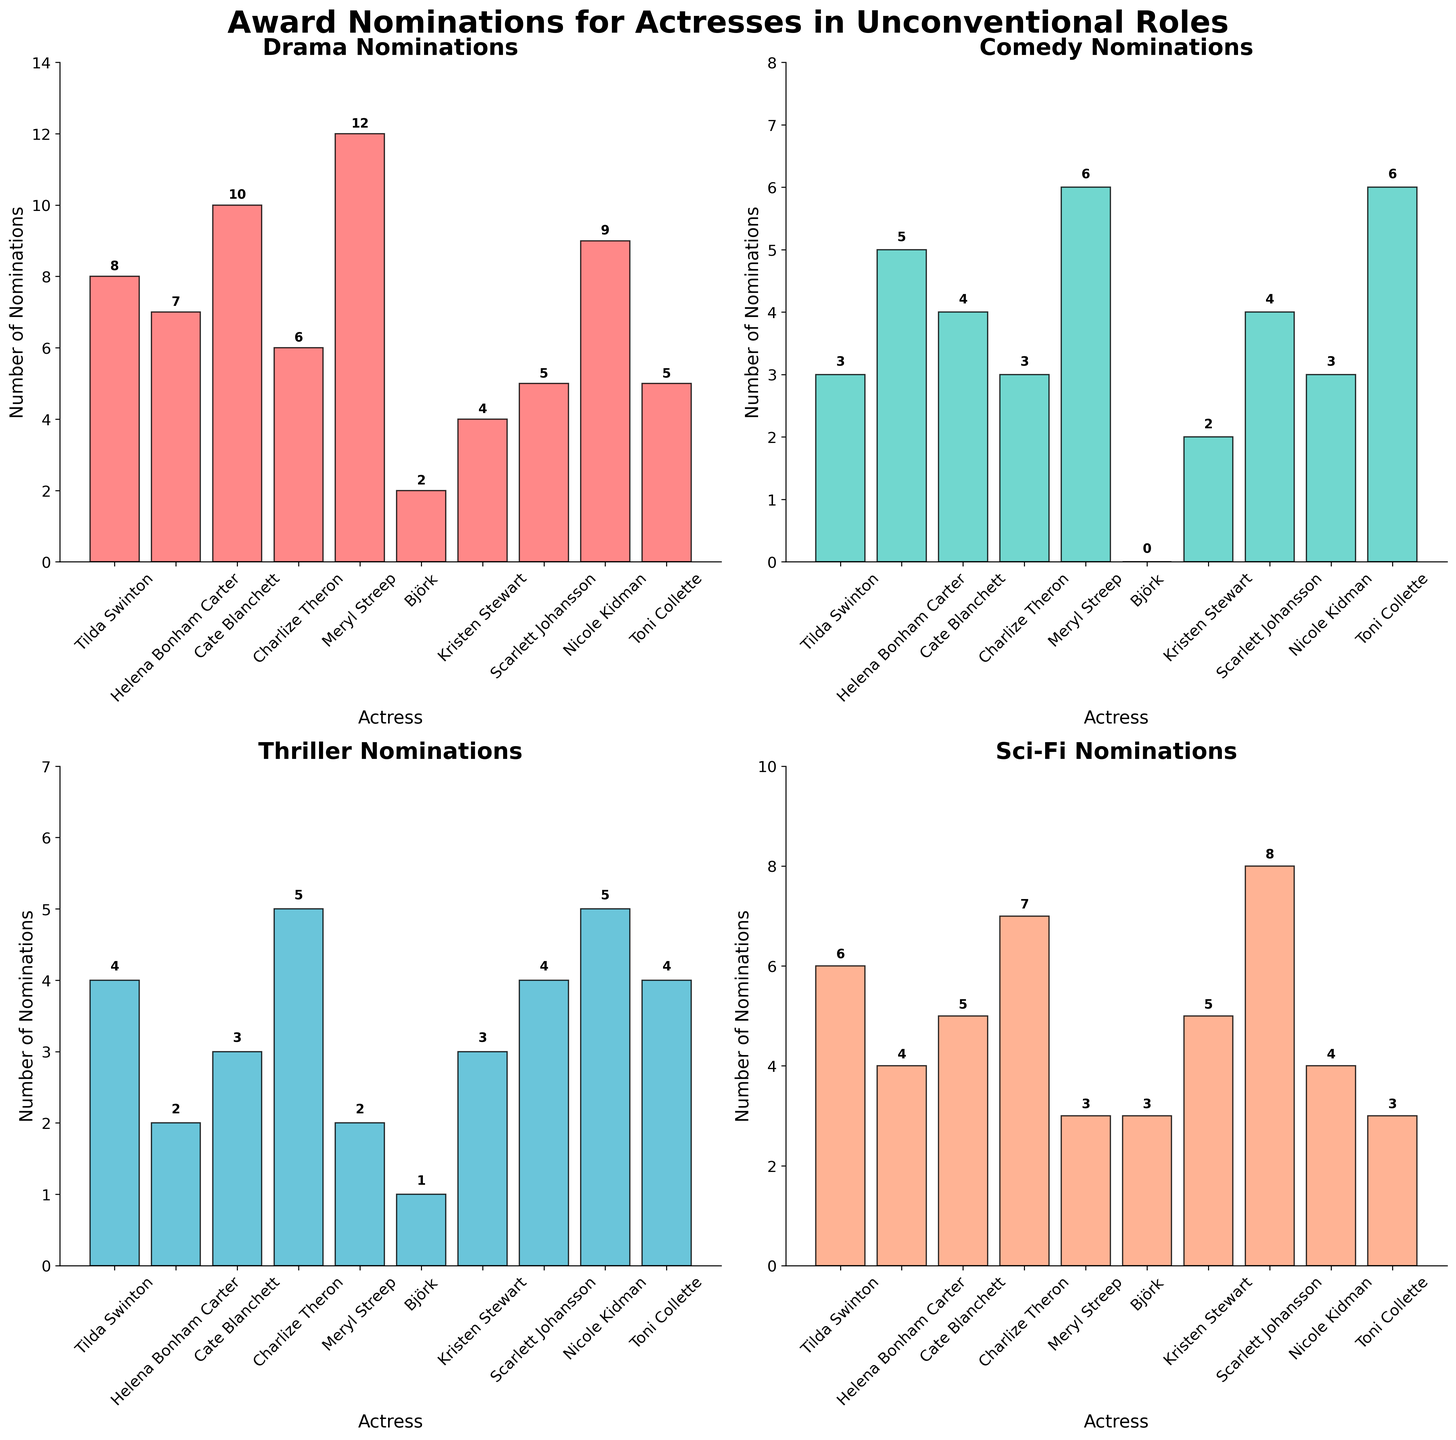Which actress has the highest number of Drama nominations? Looking at the "Drama Nominations" subplot, Meryl Streep has the highest bar. This indicates she has the most Drama nominations among all actresses.
Answer: Meryl Streep What's the total number of Sci-Fi nominations received by all actresses? Sum the numbers in the "Sci-Fi" column (6+4+5+7+3+3+5+8+4+3) which results in 48.
Answer: 48 Comparing Comedy and Thriller nominations, which genre has more nominations for Toni Collette? In the "Comedy Nominations" subplot, Toni Collette's bar is at 6, whereas in the "Thriller Nominations" subplot, it is at 4. Therefore, she has more Comedy nominations.
Answer: Comedy Who has the least number of Comedy nominations? In the "Comedy Nominations" subplot, Björk has the smallest bar with 0 nominations, making her the actress with the least Comedy nominations.
Answer: Björk How many actresses have received more than 5 nominations in Comedy? From the "Comedy Nominations" subplot, Meryl Streep (6) and Toni Collette (6) have more than 5 nominations. Thus, there are 2 actresses.
Answer: 2 What is the difference in the number of Sci-Fi nominations between Scarlett Johansson and Charlize Theron? Scarlett Johansson has 8 Sci-Fi nominations, while Charlize Theron has 7. The difference is 8 - 7 = 1.
Answer: 1 In which genre does Cate Blanchett have the highest number of nominations? Comparing Cate Blanchett's bars across all subplots, her highest bar is in the "Drama Nominations" with 10 nominations.
Answer: Drama What is the average number of Drama nominations received by these actresses? Sum all the Drama nominations (8+7+10+6+12+2+4+5+9+5 = 68) and divide by the number of actresses (10). The average is 68/10 = 6.8.
Answer: 6.8 Which two actresses have equal numbers of Thriller nominations? In the "Thriller Nominations" subplot, both Tilda Swinton and Scarlett Johansson have bars of the same height corresponding to 4 nominations.
Answer: Tilda Swinton and Scarlett Johansson 